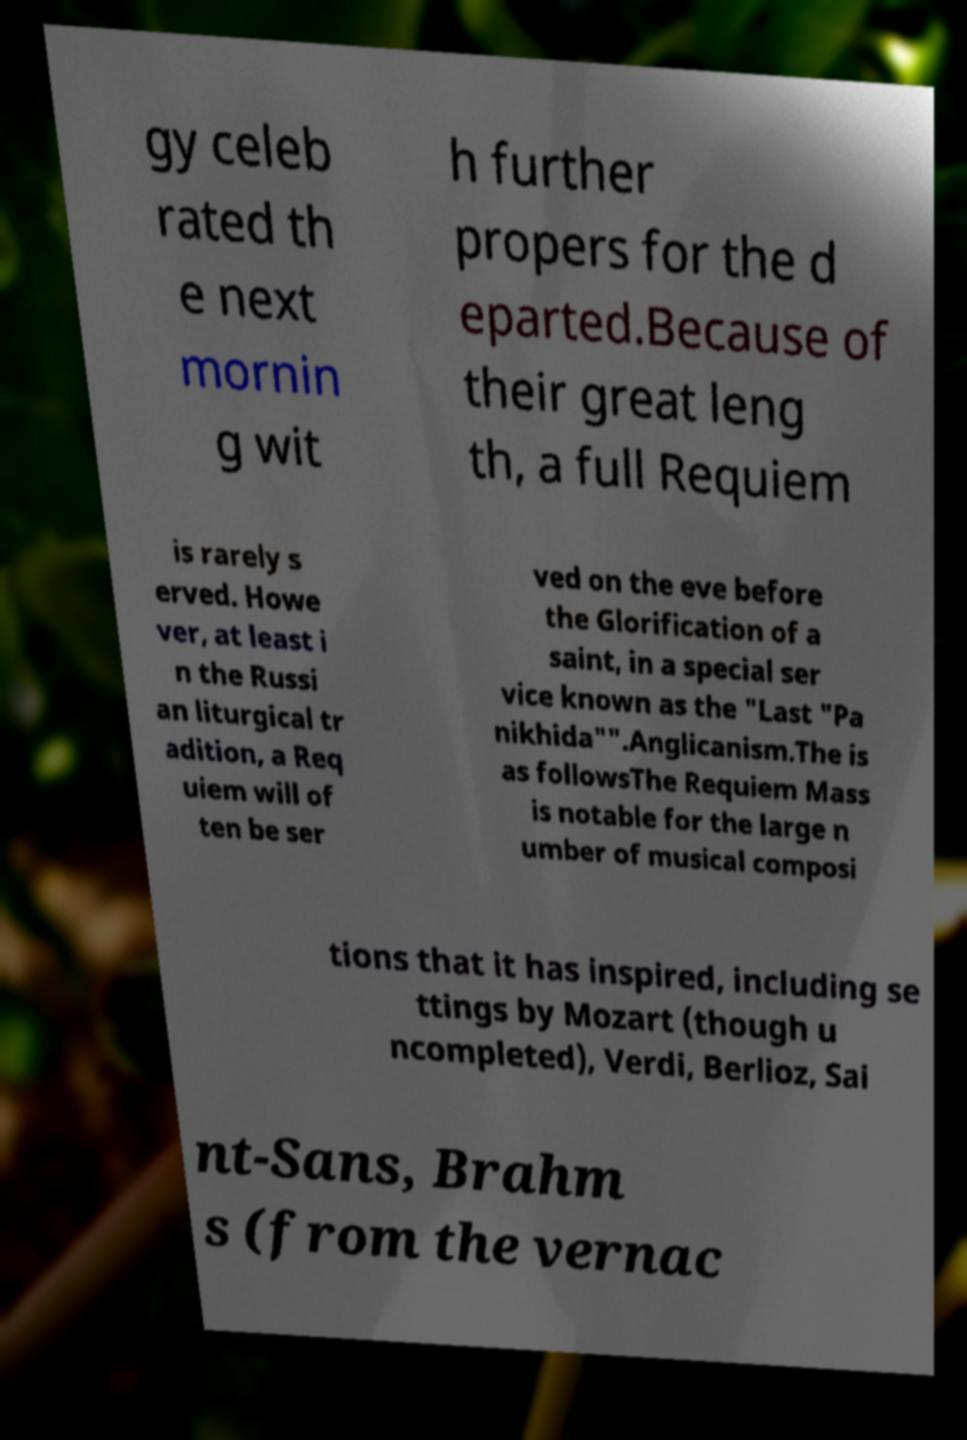Please read and relay the text visible in this image. What does it say? gy celeb rated th e next mornin g wit h further propers for the d eparted.Because of their great leng th, a full Requiem is rarely s erved. Howe ver, at least i n the Russi an liturgical tr adition, a Req uiem will of ten be ser ved on the eve before the Glorification of a saint, in a special ser vice known as the "Last "Pa nikhida"".Anglicanism.The is as followsThe Requiem Mass is notable for the large n umber of musical composi tions that it has inspired, including se ttings by Mozart (though u ncompleted), Verdi, Berlioz, Sai nt-Sans, Brahm s (from the vernac 